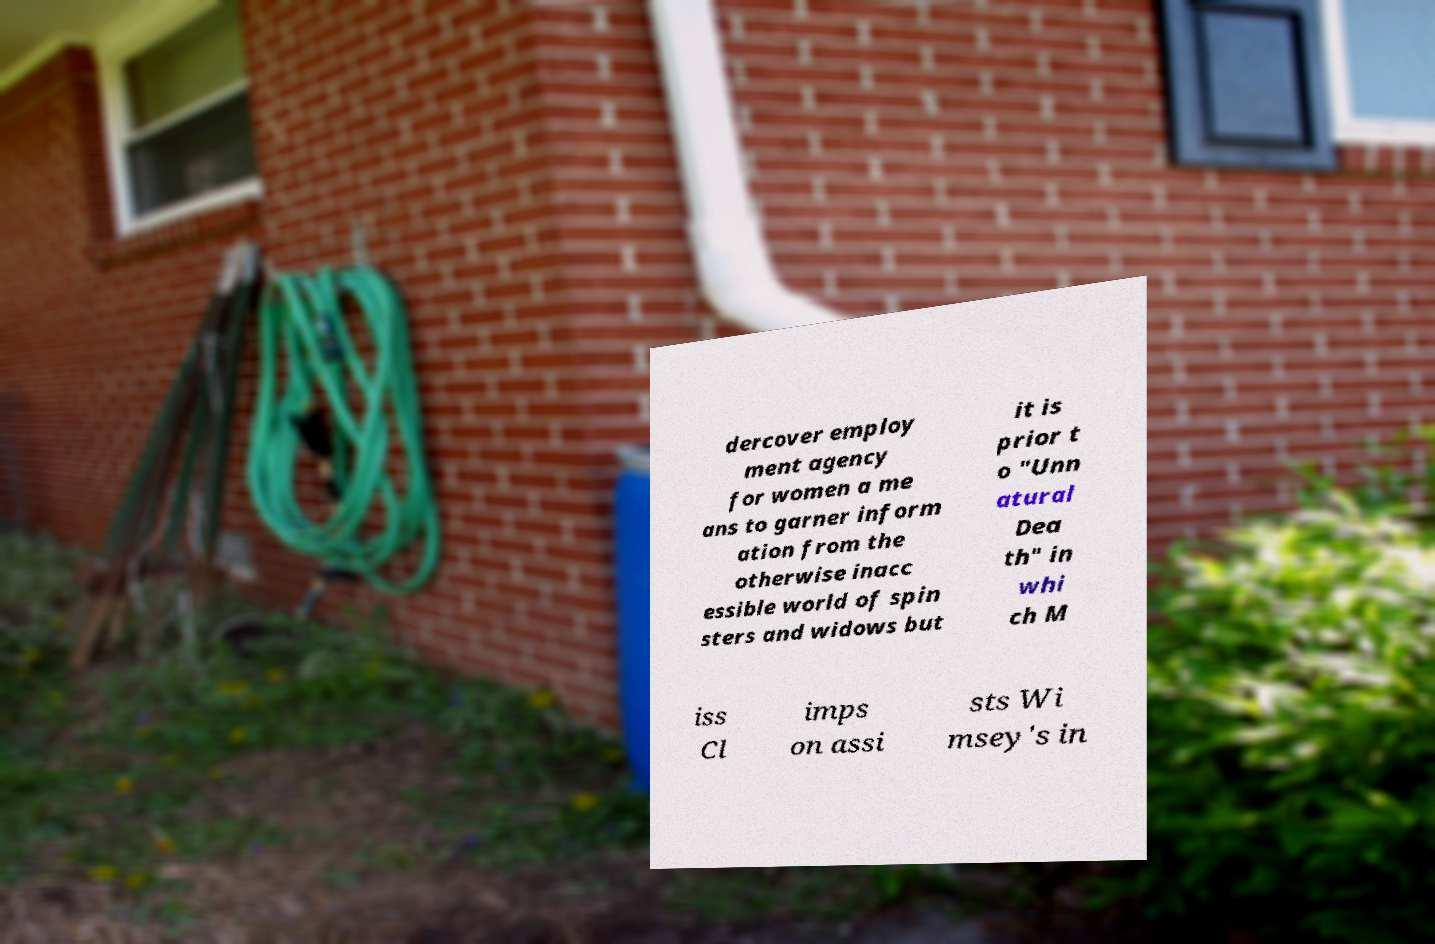I need the written content from this picture converted into text. Can you do that? dercover employ ment agency for women a me ans to garner inform ation from the otherwise inacc essible world of spin sters and widows but it is prior t o "Unn atural Dea th" in whi ch M iss Cl imps on assi sts Wi msey's in 